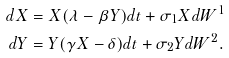Convert formula to latex. <formula><loc_0><loc_0><loc_500><loc_500>d X & = X ( \lambda - \beta Y ) d t + \sigma _ { 1 } X d W ^ { 1 } \\ d Y & = Y ( \gamma X - \delta ) d t + \sigma _ { 2 } Y d W ^ { 2 } .</formula> 